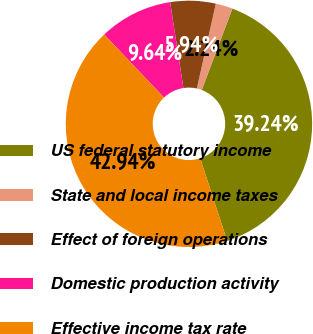<chart> <loc_0><loc_0><loc_500><loc_500><pie_chart><fcel>US federal statutory income<fcel>State and local income taxes<fcel>Effect of foreign operations<fcel>Domestic production activity<fcel>Effective income tax rate<nl><fcel>39.24%<fcel>2.24%<fcel>5.94%<fcel>9.64%<fcel>42.94%<nl></chart> 